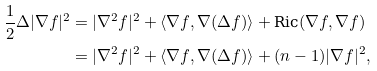<formula> <loc_0><loc_0><loc_500><loc_500>\frac { 1 } { 2 } \Delta | \nabla f | ^ { 2 } & = | \nabla ^ { 2 } f | ^ { 2 } + \langle \nabla f , \nabla ( \Delta f ) \rangle + \text {Ric} ( \nabla f , \nabla f ) \\ & = | \nabla ^ { 2 } f | ^ { 2 } + \langle \nabla f , \nabla ( \Delta f ) \rangle + ( n - 1 ) | \nabla f | ^ { 2 } , \\</formula> 